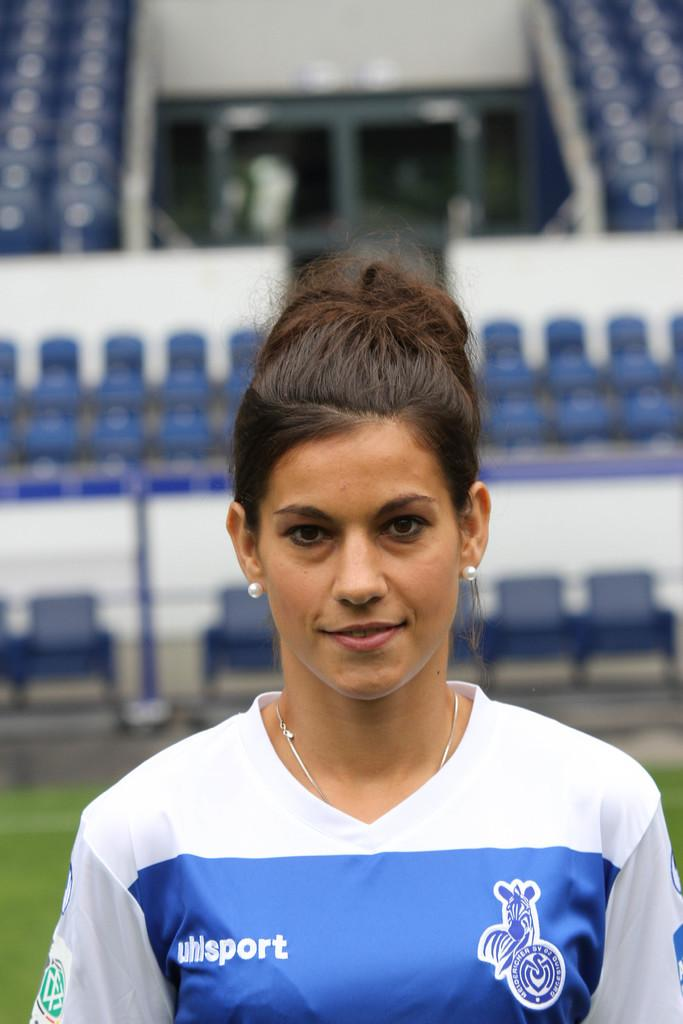<image>
Write a terse but informative summary of the picture. a lady with the word sport on her jersey 